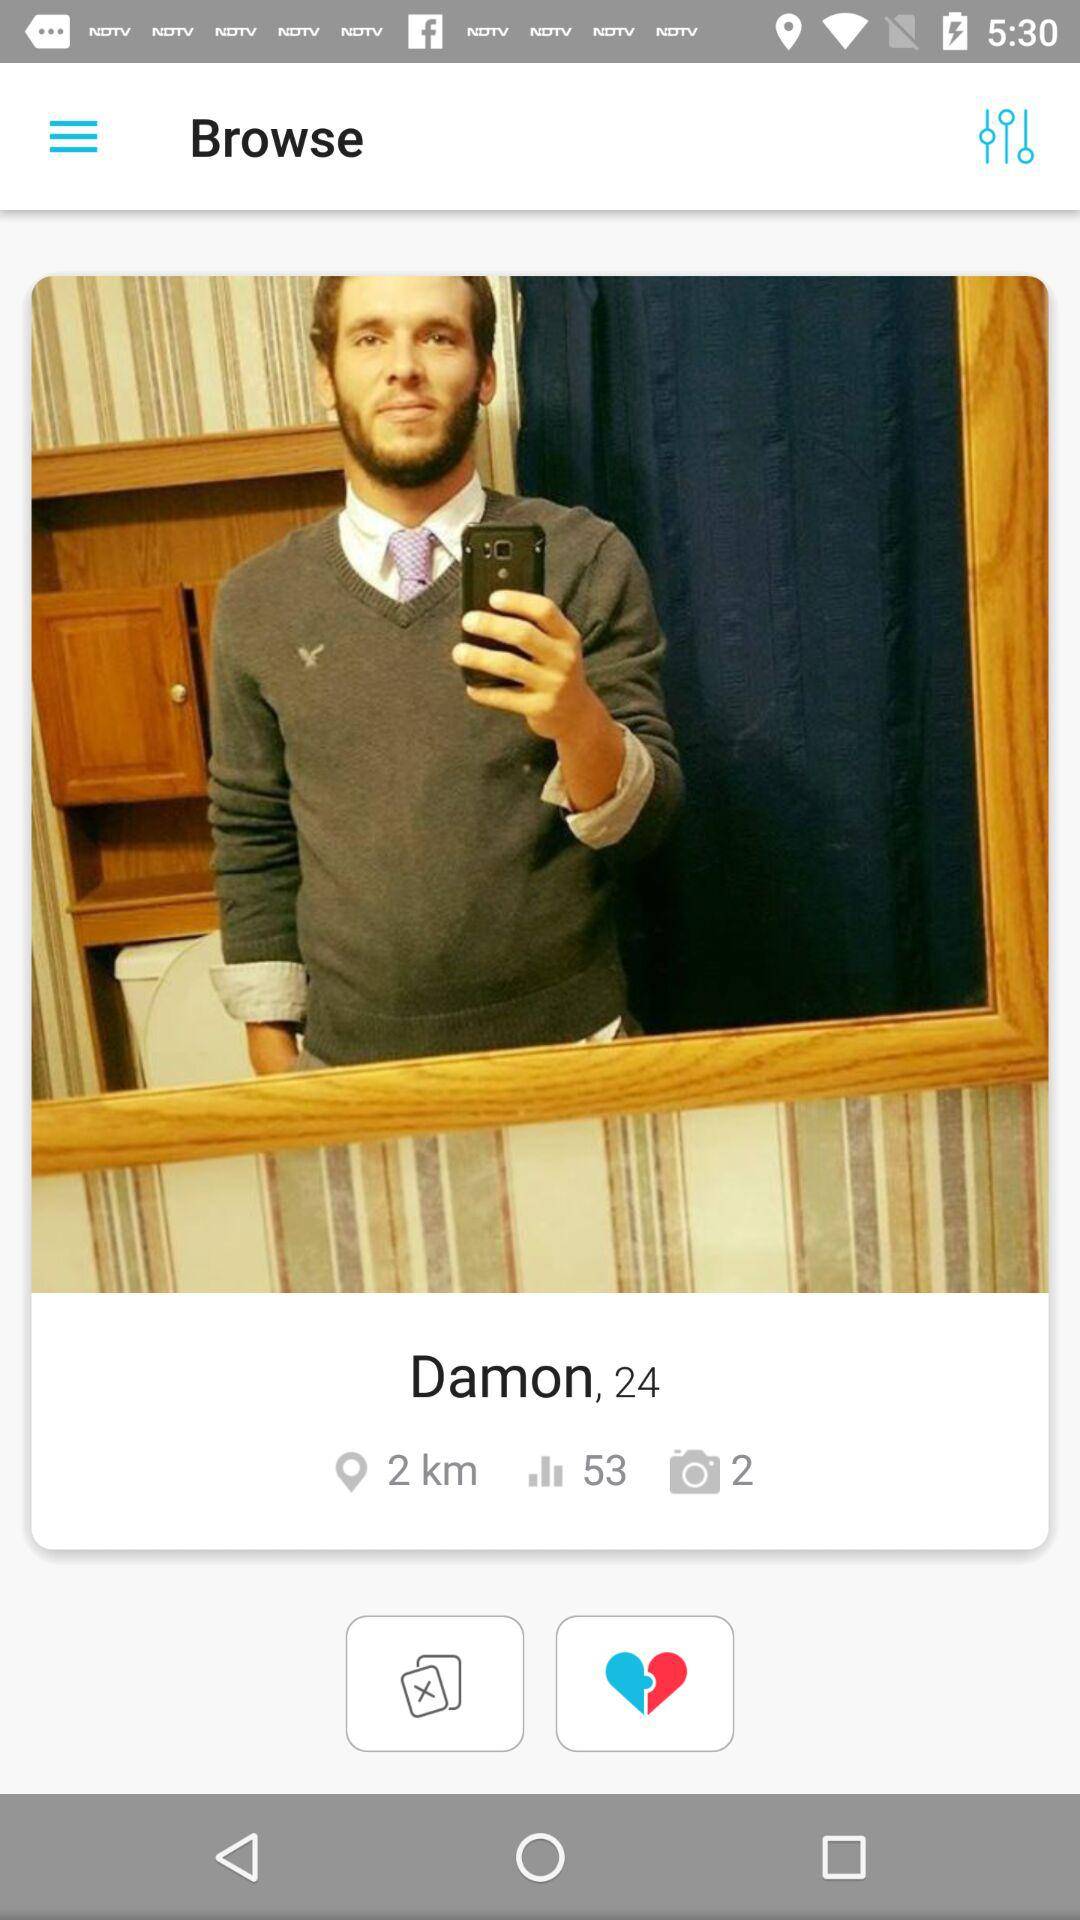What is the age? The age is 24 years old. 